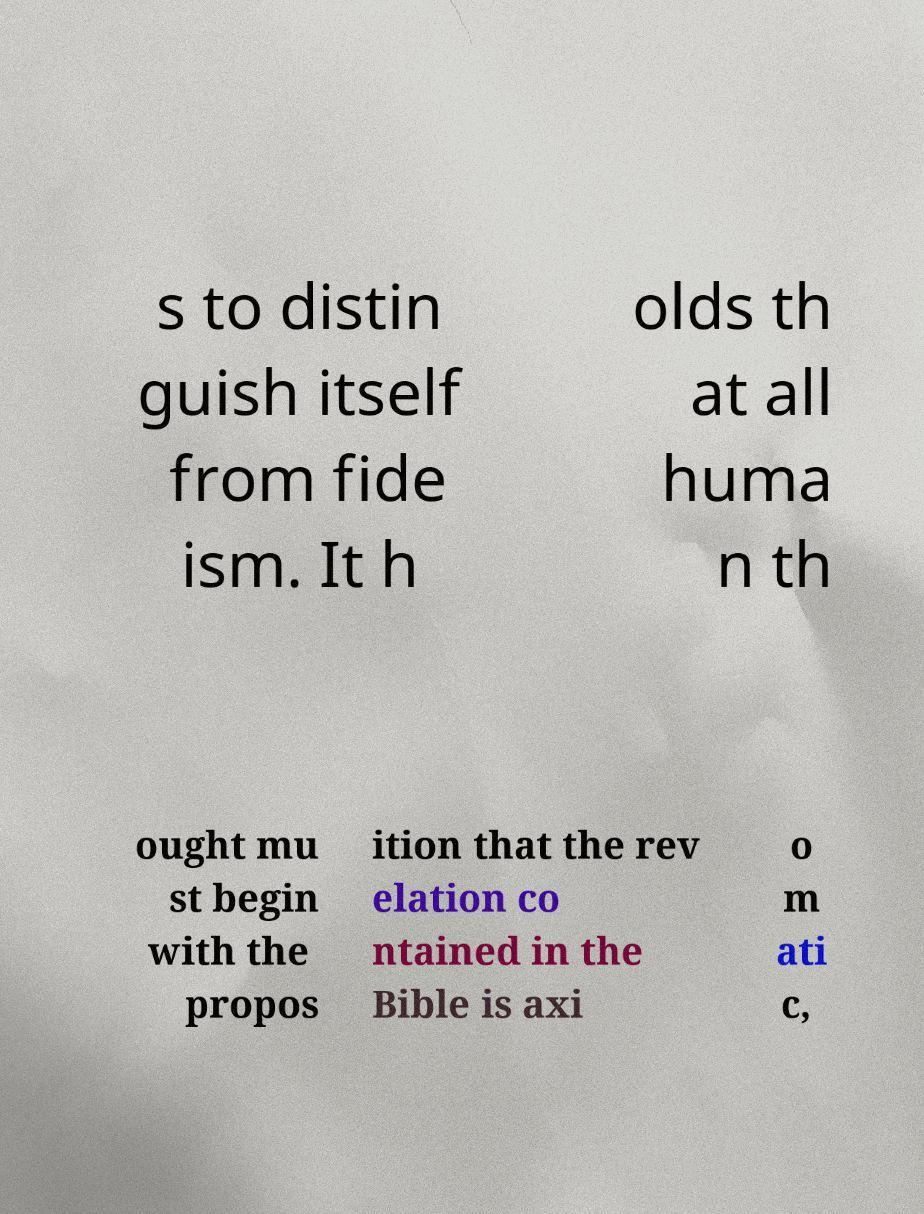Could you assist in decoding the text presented in this image and type it out clearly? s to distin guish itself from fide ism. It h olds th at all huma n th ought mu st begin with the propos ition that the rev elation co ntained in the Bible is axi o m ati c, 